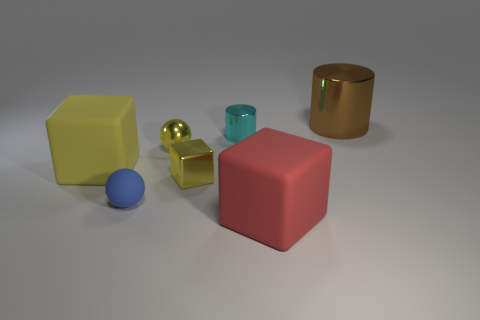Subtract all matte blocks. How many blocks are left? 1 Add 1 brown cylinders. How many objects exist? 8 Subtract all cylinders. How many objects are left? 5 Subtract all brown shiny spheres. Subtract all big matte cubes. How many objects are left? 5 Add 2 big brown objects. How many big brown objects are left? 3 Add 5 blue rubber things. How many blue rubber things exist? 6 Subtract 2 yellow blocks. How many objects are left? 5 